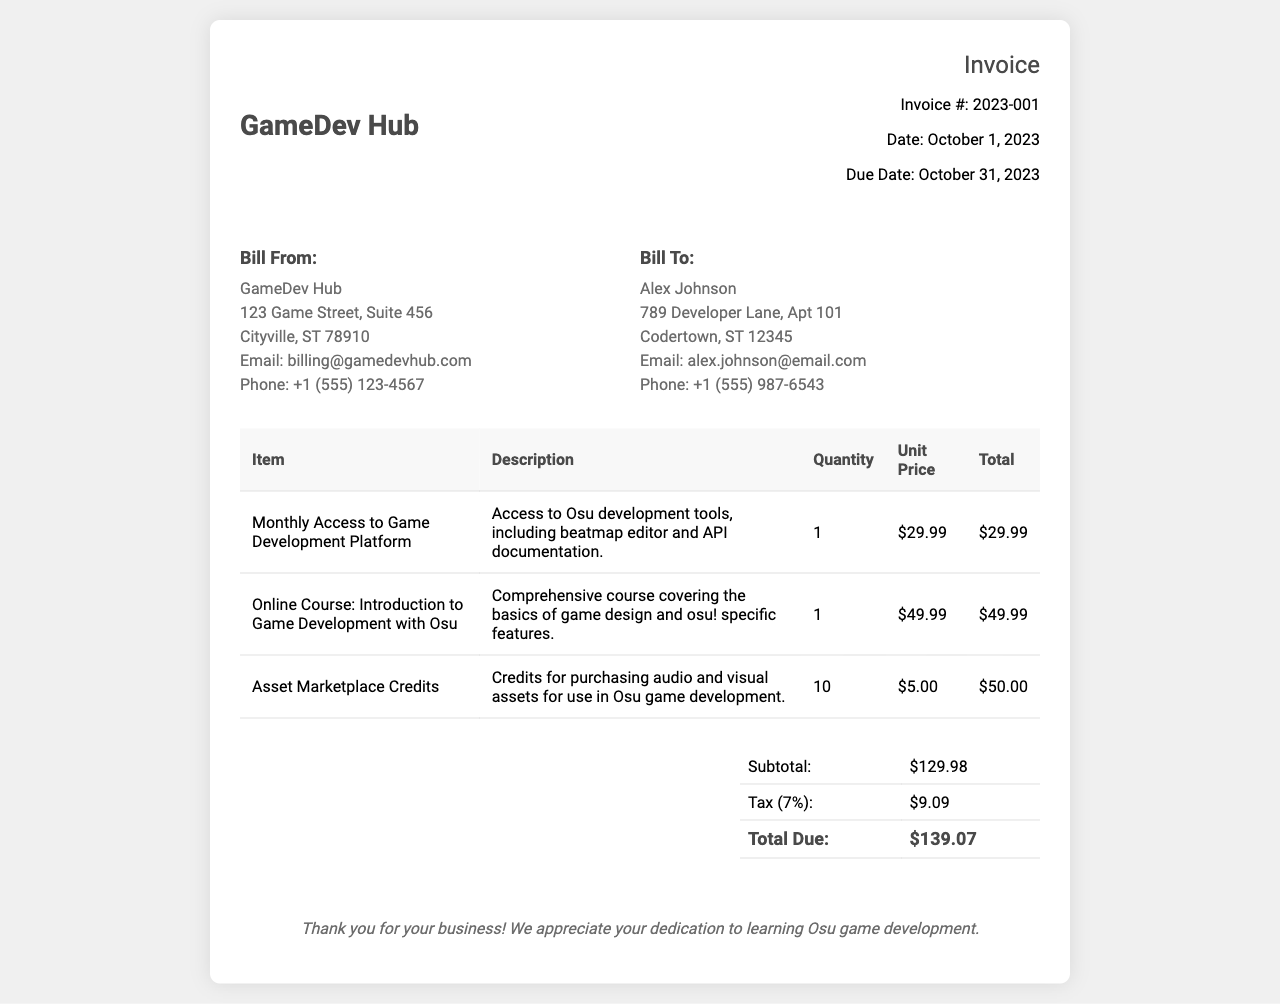What is the invoice number? The invoice number is listed prominently in the document header as Invoice #: 2023-001.
Answer: 2023-001 What is the total amount due? The total amount due is mentioned in the total table section as Total Due: $139.07.
Answer: $139.07 Who is the billed individual? The document specifies the billed individual in the "Bill To" section as Alex Johnson.
Answer: Alex Johnson What is the date of the invoice? The date of the invoice is provided in the invoice info section, mentioned as Date: October 1, 2023.
Answer: October 1, 2023 How many asset marketplace credits were included? The document states that there are 10 Asset Marketplace Credits listed in the items table.
Answer: 10 What is the unit price of the online course? The unit price for the online course is indicated in the items table as $49.99.
Answer: $49.99 What is the tax percentage applied? The tax is shown as 7% in the total table section under the Tax line.
Answer: 7% What is the description of the first item? The description for the first item "Monthly Access to Game Development Platform" is detailed in the items table.
Answer: Access to Osu development tools, including beatmap editor and API documentation What is the billing email address for GameDev Hub? The billing email address for GameDev Hub is mentioned in the "Bill From" section as billing@gamedevhub.com.
Answer: billing@gamedevhub.com 